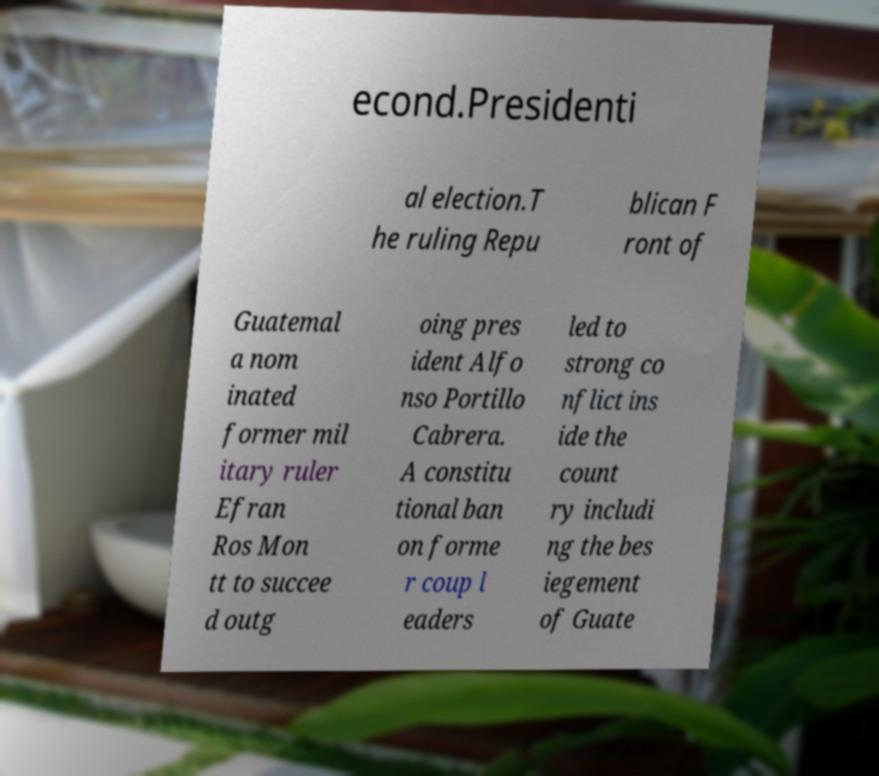Can you accurately transcribe the text from the provided image for me? econd.Presidenti al election.T he ruling Repu blican F ront of Guatemal a nom inated former mil itary ruler Efran Ros Mon tt to succee d outg oing pres ident Alfo nso Portillo Cabrera. A constitu tional ban on forme r coup l eaders led to strong co nflict ins ide the count ry includi ng the bes iegement of Guate 